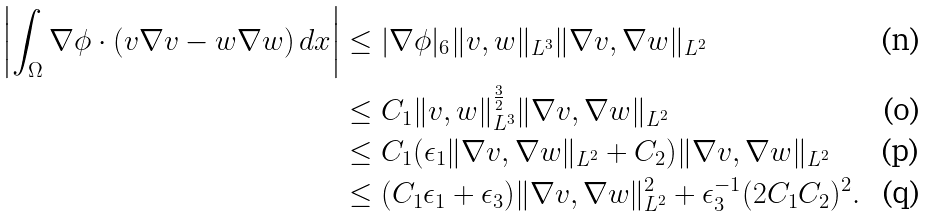<formula> <loc_0><loc_0><loc_500><loc_500>\left | \int _ { \Omega } \nabla \phi \cdot ( v \nabla v - w \nabla w ) \, d x \right | & \leq | \nabla \phi | _ { 6 } \| v , w \| _ { L ^ { 3 } } \| \nabla v , \nabla w \| _ { L ^ { 2 } } \\ & \leq C _ { 1 } \| v , w \| _ { L ^ { 3 } } ^ { \frac { 3 } { 2 } } \| \nabla v , \nabla w \| _ { L ^ { 2 } } \\ & \leq C _ { 1 } ( \epsilon _ { 1 } \| \nabla v , \nabla w \| _ { L ^ { 2 } } + C _ { 2 } ) \| \nabla v , \nabla w \| _ { L ^ { 2 } } \\ & \leq ( C _ { 1 } \epsilon _ { 1 } + \epsilon _ { 3 } ) \| \nabla v , \nabla w \| _ { L ^ { 2 } } ^ { 2 } + \epsilon _ { 3 } ^ { - 1 } ( 2 C _ { 1 } C _ { 2 } ) ^ { 2 } .</formula> 